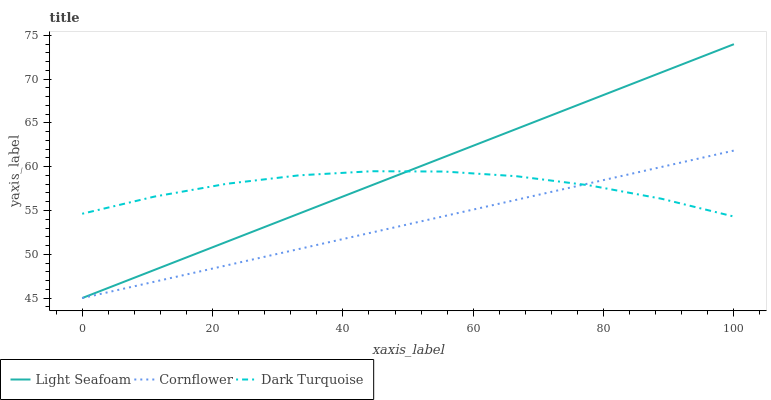Does Cornflower have the minimum area under the curve?
Answer yes or no. Yes. Does Light Seafoam have the maximum area under the curve?
Answer yes or no. Yes. Does Dark Turquoise have the minimum area under the curve?
Answer yes or no. No. Does Dark Turquoise have the maximum area under the curve?
Answer yes or no. No. Is Light Seafoam the smoothest?
Answer yes or no. Yes. Is Dark Turquoise the roughest?
Answer yes or no. Yes. Is Dark Turquoise the smoothest?
Answer yes or no. No. Is Light Seafoam the roughest?
Answer yes or no. No. Does Cornflower have the lowest value?
Answer yes or no. Yes. Does Dark Turquoise have the lowest value?
Answer yes or no. No. Does Light Seafoam have the highest value?
Answer yes or no. Yes. Does Dark Turquoise have the highest value?
Answer yes or no. No. Does Cornflower intersect Light Seafoam?
Answer yes or no. Yes. Is Cornflower less than Light Seafoam?
Answer yes or no. No. Is Cornflower greater than Light Seafoam?
Answer yes or no. No. 